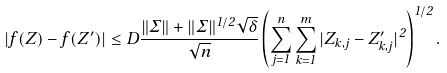Convert formula to latex. <formula><loc_0><loc_0><loc_500><loc_500>| f ( Z ) - f ( Z ^ { \prime } ) | \leq D \frac { \| \Sigma \| + \| \Sigma \| ^ { 1 / 2 } \sqrt { \delta } } { \sqrt { n } } \left ( \sum _ { j = 1 } ^ { n } \sum _ { k = 1 } ^ { m } | Z _ { k , j } - Z _ { k , j } ^ { \prime } | ^ { 2 } \right ) ^ { 1 / 2 } .</formula> 